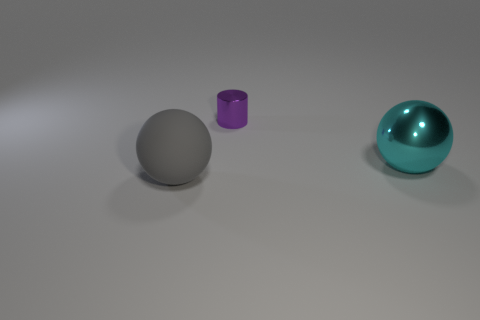Add 1 large red cylinders. How many objects exist? 4 Subtract all spheres. How many objects are left? 1 Subtract 0 green cylinders. How many objects are left? 3 Subtract all cyan cylinders. Subtract all purple balls. How many cylinders are left? 1 Subtract all small metal objects. Subtract all small gray shiny cubes. How many objects are left? 2 Add 2 shiny cylinders. How many shiny cylinders are left? 3 Add 3 green metallic blocks. How many green metallic blocks exist? 3 